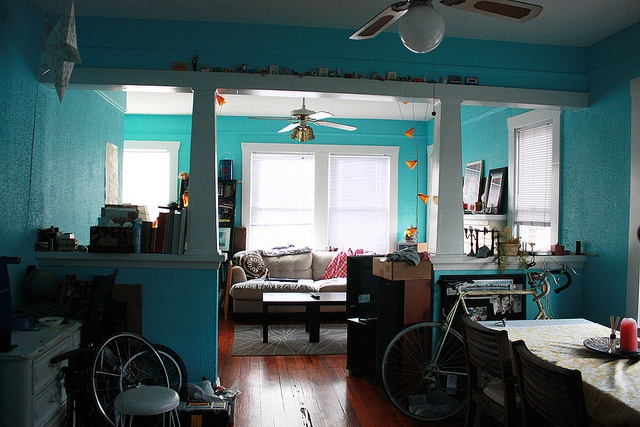Describe the objects in this image and their specific colors. I can see bicycle in black, teal, gray, and darkgray tones, dining table in black, lightgray, darkgray, and beige tones, couch in black, gray, white, and darkgray tones, bicycle in black, gray, teal, and maroon tones, and chair in black, gray, and darkgray tones in this image. 